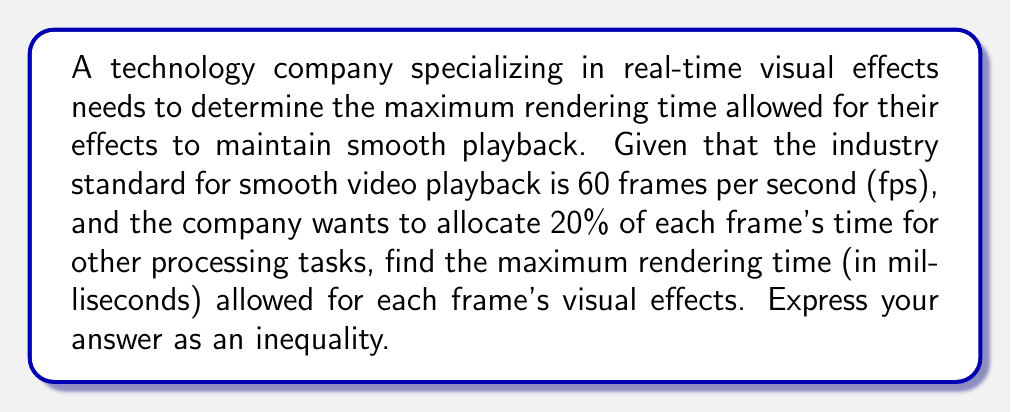Provide a solution to this math problem. To solve this problem, we need to follow these steps:

1. Calculate the total time available for each frame:
   $$ \text{Time per frame} = \frac{1 \text{ second}}{60 \text{ frames}} = \frac{1}{60} \text{ seconds} $$

2. Convert the time per frame to milliseconds:
   $$ \frac{1}{60} \text{ seconds} \times 1000 \text{ ms/s} = \frac{1000}{60} \text{ ms} \approx 16.67 \text{ ms} $$

3. Calculate the time available for rendering, considering the 20% allocation for other tasks:
   $$ \text{Available rendering time} = 16.67 \text{ ms} \times (1 - 0.20) = 16.67 \text{ ms} \times 0.80 = 13.33 \text{ ms} $$

4. Express the maximum rendering time as an inequality:
   $$ \text{Rendering time} \leq 13.33 \text{ ms} $$

This inequality states that the rendering time for each frame's visual effects must be less than or equal to 13.33 milliseconds to maintain smooth playback at 60 fps while allocating 20% of each frame's time for other processing tasks.
Answer: $$ \text{Rendering time} \leq 13.33 \text{ ms} $$ 